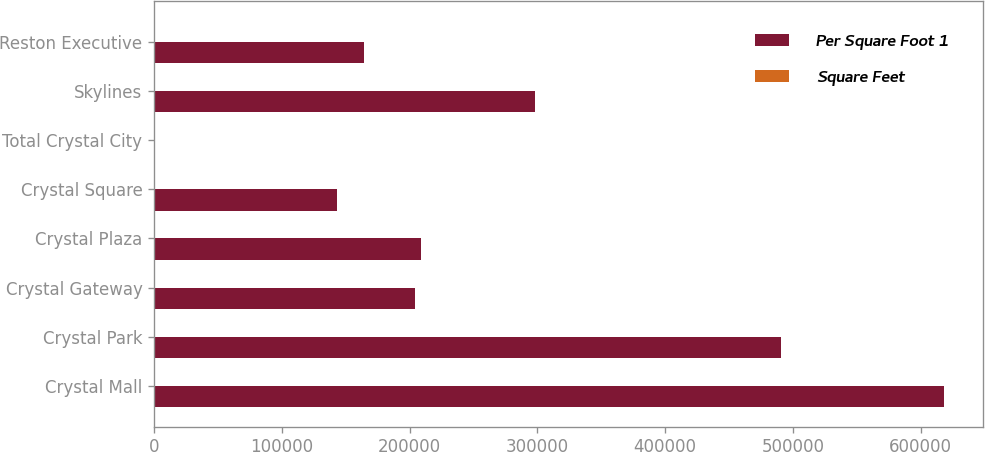Convert chart to OTSL. <chart><loc_0><loc_0><loc_500><loc_500><stacked_bar_chart><ecel><fcel>Crystal Mall<fcel>Crystal Park<fcel>Crystal Gateway<fcel>Crystal Plaza<fcel>Crystal Square<fcel>Total Crystal City<fcel>Skylines<fcel>Reston Executive<nl><fcel>Per Square Foot 1<fcel>618000<fcel>491000<fcel>204000<fcel>209000<fcel>143000<fcel>32.73<fcel>298000<fcel>164000<nl><fcel>Square Feet<fcel>31.19<fcel>32.68<fcel>27.27<fcel>31.98<fcel>32.73<fcel>31.36<fcel>26.96<fcel>26.33<nl></chart> 